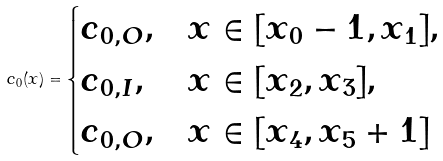<formula> <loc_0><loc_0><loc_500><loc_500>c _ { 0 } ( x ) = \begin{cases} c _ { 0 , O } , & x \in [ x _ { 0 } - 1 , x _ { 1 } ] , \\ c _ { 0 , I } , & x \in [ x _ { 2 } , x _ { 3 } ] , \\ c _ { 0 , O } , & x \in [ x _ { 4 } , x _ { 5 } + 1 ] \end{cases}</formula> 